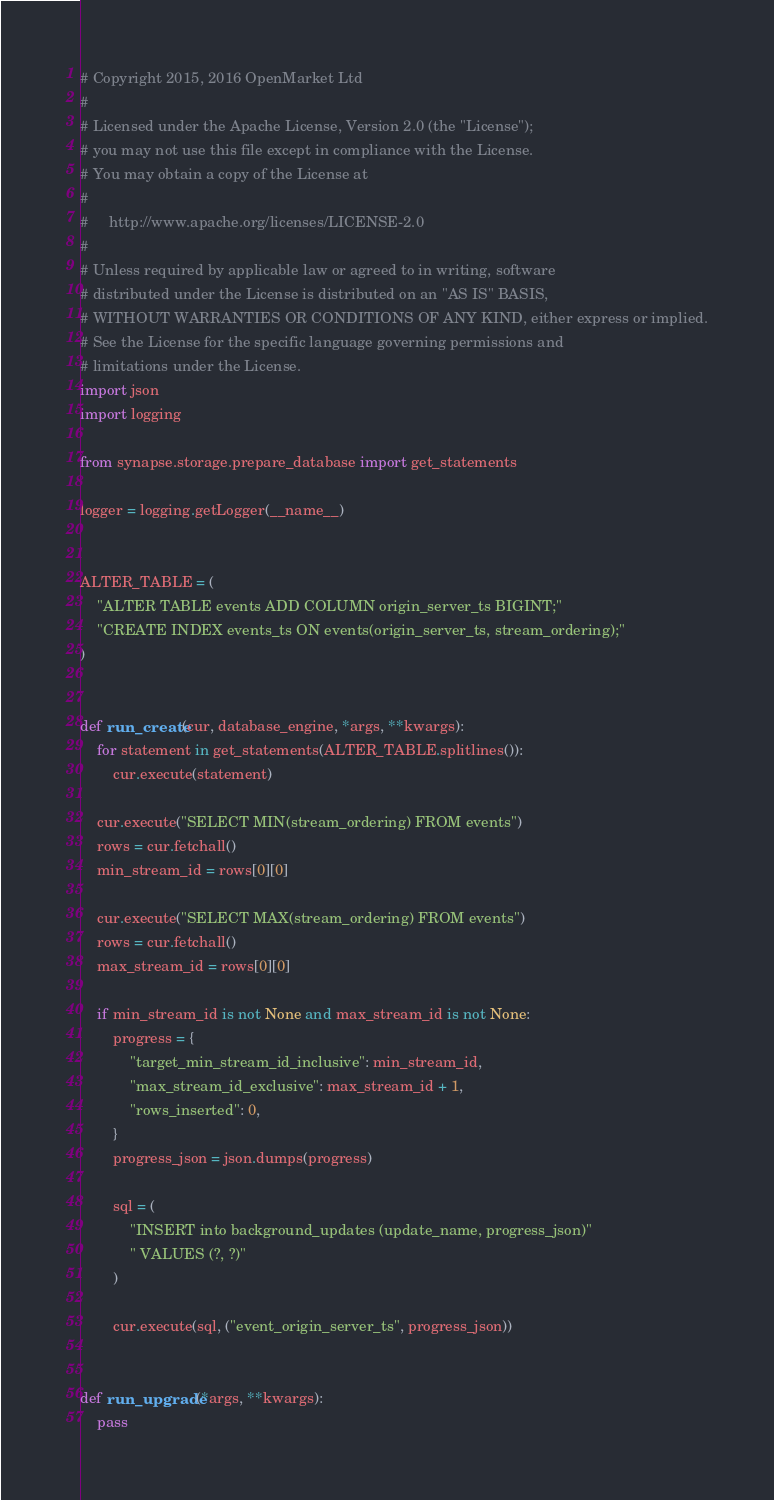Convert code to text. <code><loc_0><loc_0><loc_500><loc_500><_Python_># Copyright 2015, 2016 OpenMarket Ltd
#
# Licensed under the Apache License, Version 2.0 (the "License");
# you may not use this file except in compliance with the License.
# You may obtain a copy of the License at
#
#     http://www.apache.org/licenses/LICENSE-2.0
#
# Unless required by applicable law or agreed to in writing, software
# distributed under the License is distributed on an "AS IS" BASIS,
# WITHOUT WARRANTIES OR CONDITIONS OF ANY KIND, either express or implied.
# See the License for the specific language governing permissions and
# limitations under the License.
import json
import logging

from synapse.storage.prepare_database import get_statements

logger = logging.getLogger(__name__)


ALTER_TABLE = (
    "ALTER TABLE events ADD COLUMN origin_server_ts BIGINT;"
    "CREATE INDEX events_ts ON events(origin_server_ts, stream_ordering);"
)


def run_create(cur, database_engine, *args, **kwargs):
    for statement in get_statements(ALTER_TABLE.splitlines()):
        cur.execute(statement)

    cur.execute("SELECT MIN(stream_ordering) FROM events")
    rows = cur.fetchall()
    min_stream_id = rows[0][0]

    cur.execute("SELECT MAX(stream_ordering) FROM events")
    rows = cur.fetchall()
    max_stream_id = rows[0][0]

    if min_stream_id is not None and max_stream_id is not None:
        progress = {
            "target_min_stream_id_inclusive": min_stream_id,
            "max_stream_id_exclusive": max_stream_id + 1,
            "rows_inserted": 0,
        }
        progress_json = json.dumps(progress)

        sql = (
            "INSERT into background_updates (update_name, progress_json)"
            " VALUES (?, ?)"
        )

        cur.execute(sql, ("event_origin_server_ts", progress_json))


def run_upgrade(*args, **kwargs):
    pass
</code> 